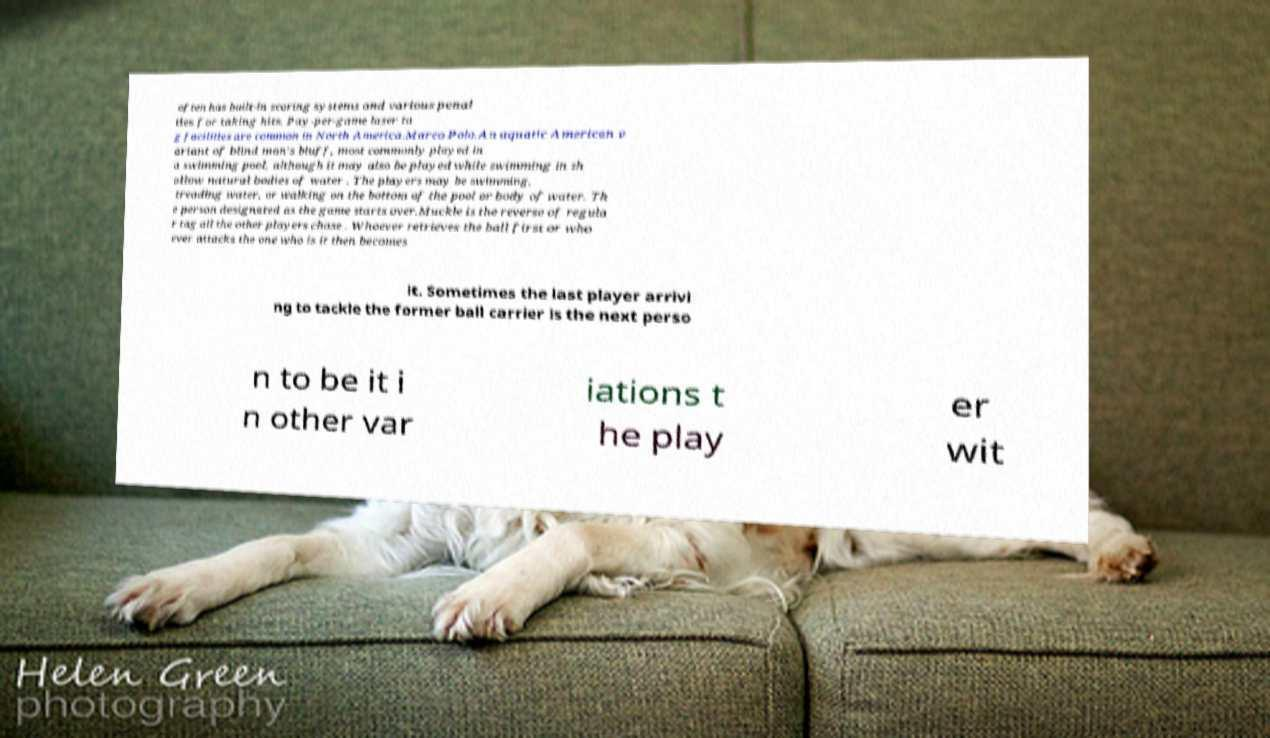There's text embedded in this image that I need extracted. Can you transcribe it verbatim? often has built-in scoring systems and various penal ties for taking hits. Pay-per-game laser ta g facilities are common in North America.Marco Polo.An aquatic American v ariant of blind man's bluff, most commonly played in a swimming pool, although it may also be played while swimming in sh allow natural bodies of water . The players may be swimming, treading water, or walking on the bottom of the pool or body of water. Th e person designated as the game starts over.Muckle is the reverse of regula r tag all the other players chase . Whoever retrieves the ball first or who ever attacks the one who is it then becomes it. Sometimes the last player arrivi ng to tackle the former ball carrier is the next perso n to be it i n other var iations t he play er wit 